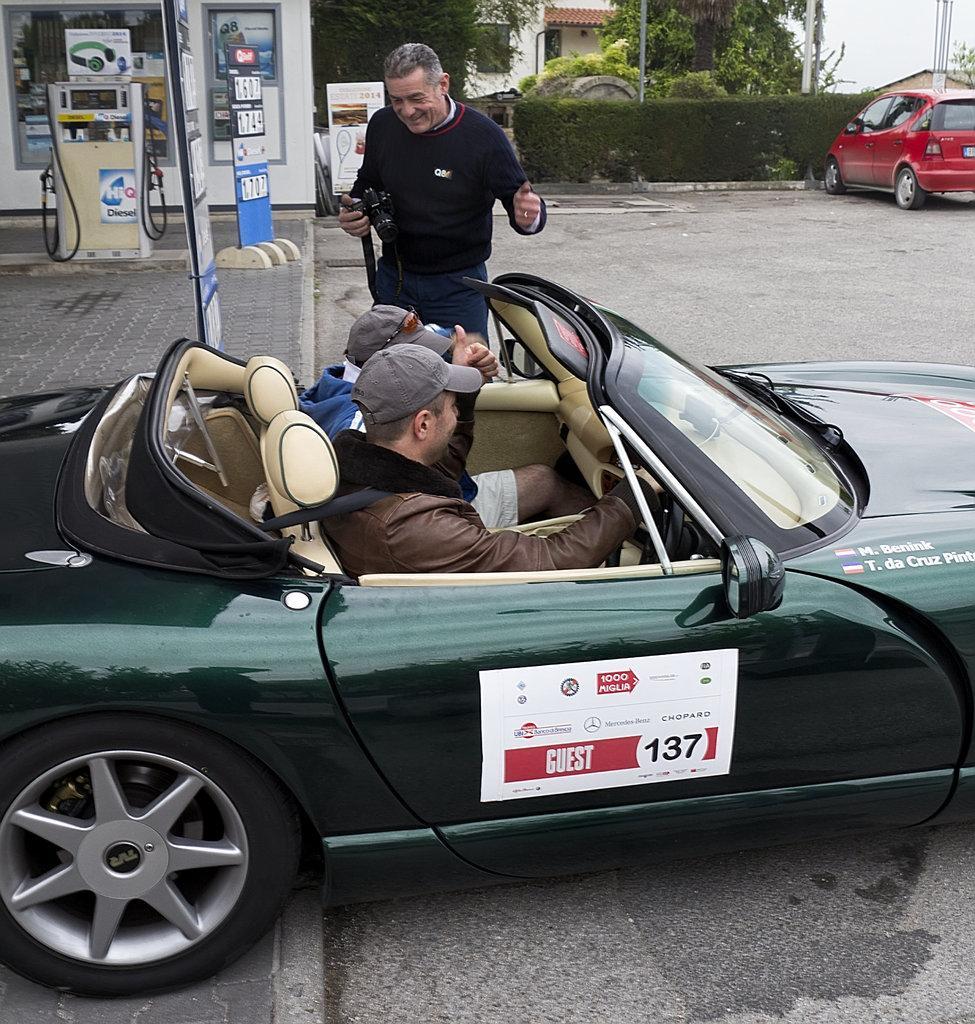How would you summarize this image in a sentence or two? In this picture we can see three people, two are seated in the car, and one person is holding camera in his hand, they are all in the gas station, in the background we can see a hoarding, car, couple of trees, poles and buildings. 